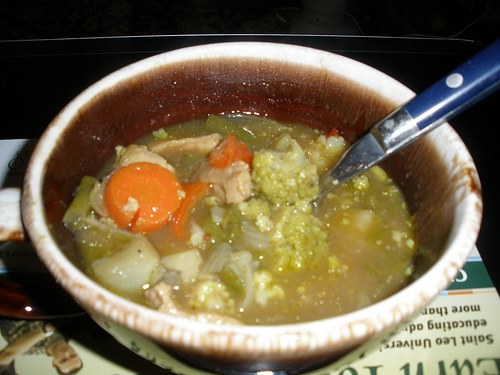What is the food to the right of the vegetables that are to the right of the onion called? The food to the right of the vegetables, which are to the right of the onion, is soup. 